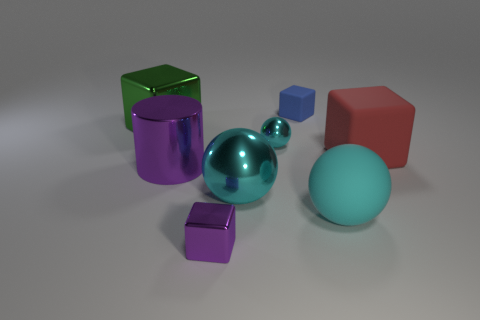How many cyan spheres must be subtracted to get 2 cyan spheres? 1 Add 2 red matte cubes. How many objects exist? 10 Subtract all large green blocks. How many blocks are left? 3 Subtract all blue cubes. How many cubes are left? 3 Subtract 1 balls. How many balls are left? 2 Subtract all purple cubes. Subtract all brown cylinders. How many cubes are left? 3 Add 1 cyan balls. How many cyan balls are left? 4 Add 8 red shiny cubes. How many red shiny cubes exist? 8 Subtract 0 purple spheres. How many objects are left? 8 Subtract all cylinders. How many objects are left? 7 